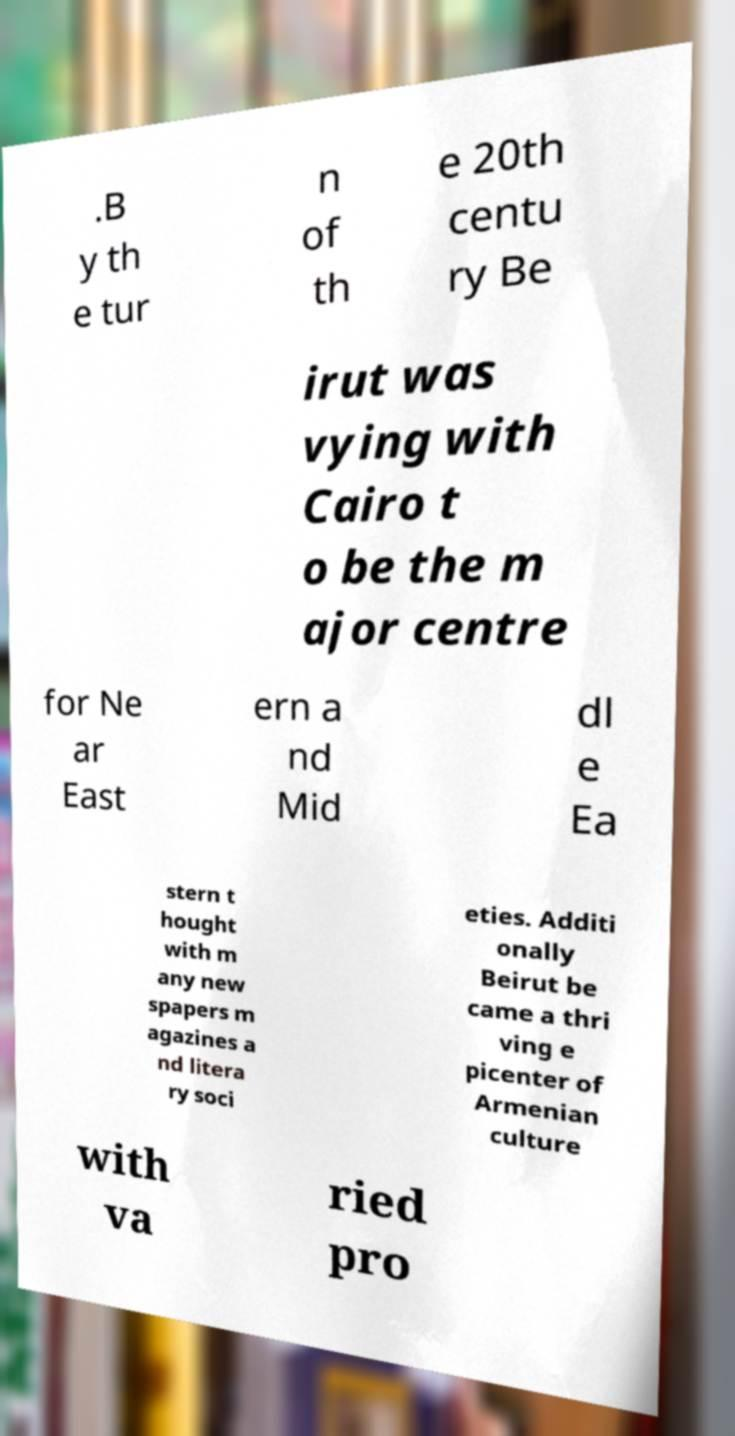There's text embedded in this image that I need extracted. Can you transcribe it verbatim? .B y th e tur n of th e 20th centu ry Be irut was vying with Cairo t o be the m ajor centre for Ne ar East ern a nd Mid dl e Ea stern t hought with m any new spapers m agazines a nd litera ry soci eties. Additi onally Beirut be came a thri ving e picenter of Armenian culture with va ried pro 